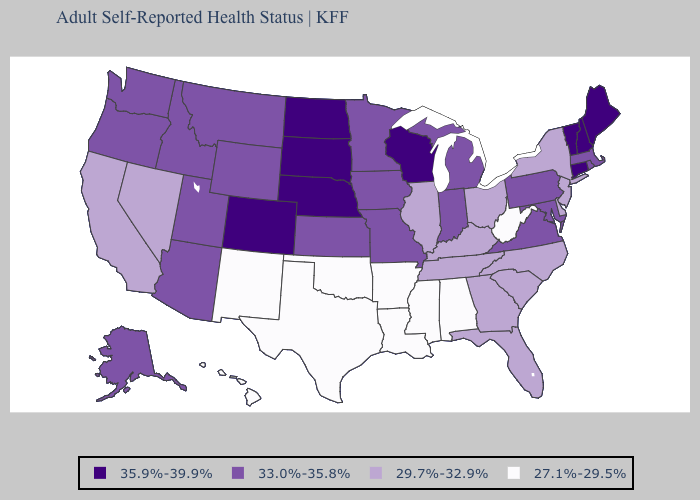Name the states that have a value in the range 33.0%-35.8%?
Quick response, please. Alaska, Arizona, Idaho, Indiana, Iowa, Kansas, Maryland, Massachusetts, Michigan, Minnesota, Missouri, Montana, Oregon, Pennsylvania, Rhode Island, Utah, Virginia, Washington, Wyoming. What is the lowest value in the MidWest?
Short answer required. 29.7%-32.9%. Does Arizona have a lower value than Wisconsin?
Give a very brief answer. Yes. Name the states that have a value in the range 33.0%-35.8%?
Write a very short answer. Alaska, Arizona, Idaho, Indiana, Iowa, Kansas, Maryland, Massachusetts, Michigan, Minnesota, Missouri, Montana, Oregon, Pennsylvania, Rhode Island, Utah, Virginia, Washington, Wyoming. Name the states that have a value in the range 27.1%-29.5%?
Give a very brief answer. Alabama, Arkansas, Hawaii, Louisiana, Mississippi, New Mexico, Oklahoma, Texas, West Virginia. Does the map have missing data?
Write a very short answer. No. Name the states that have a value in the range 35.9%-39.9%?
Quick response, please. Colorado, Connecticut, Maine, Nebraska, New Hampshire, North Dakota, South Dakota, Vermont, Wisconsin. What is the lowest value in the West?
Give a very brief answer. 27.1%-29.5%. Among the states that border Maine , which have the lowest value?
Be succinct. New Hampshire. Among the states that border Wyoming , which have the highest value?
Keep it brief. Colorado, Nebraska, South Dakota. Does Texas have a higher value than New York?
Write a very short answer. No. Does the first symbol in the legend represent the smallest category?
Quick response, please. No. Name the states that have a value in the range 33.0%-35.8%?
Be succinct. Alaska, Arizona, Idaho, Indiana, Iowa, Kansas, Maryland, Massachusetts, Michigan, Minnesota, Missouri, Montana, Oregon, Pennsylvania, Rhode Island, Utah, Virginia, Washington, Wyoming. Does Texas have a higher value than Virginia?
Short answer required. No. What is the value of California?
Quick response, please. 29.7%-32.9%. 